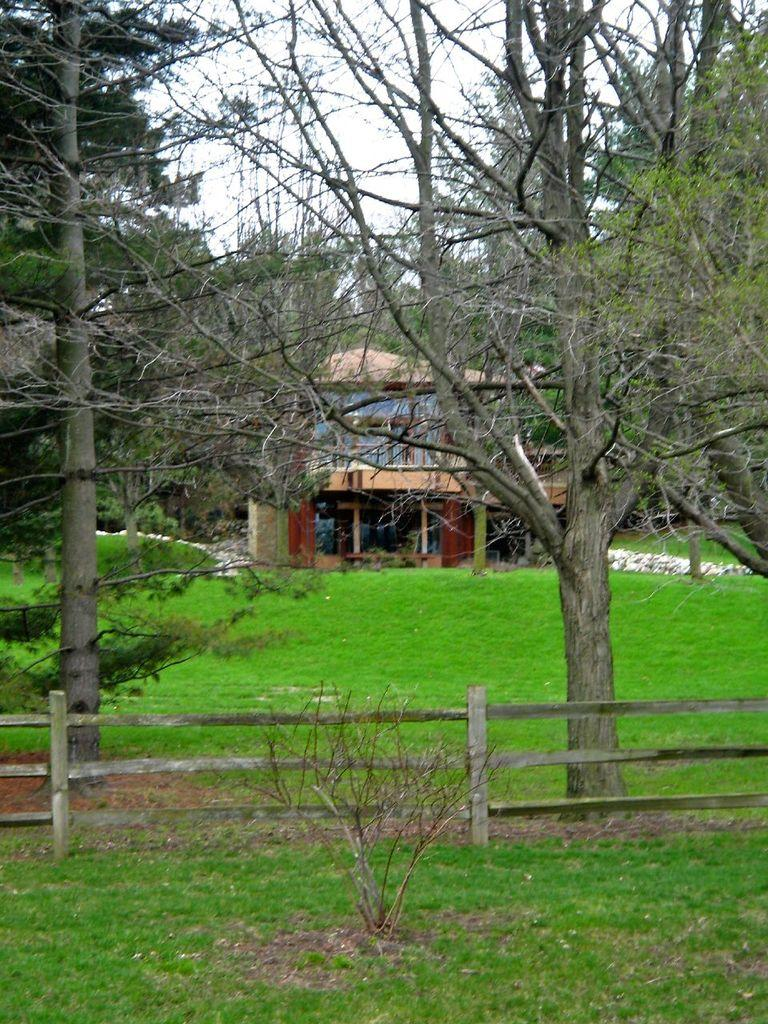What type of ground surface is visible in the image? There is grass on the ground in the image. What is located in the front of the image? There is a wooden fence in the front of the image. What can be seen in the background of the image? There are trees and a building in the background of the image. What is the condition of the sky in the image? The sky is cloudy in the image. What type of marble is used to construct the building in the image? There is no marble mentioned or visible in the image; the building is not described in terms of its construction materials. 